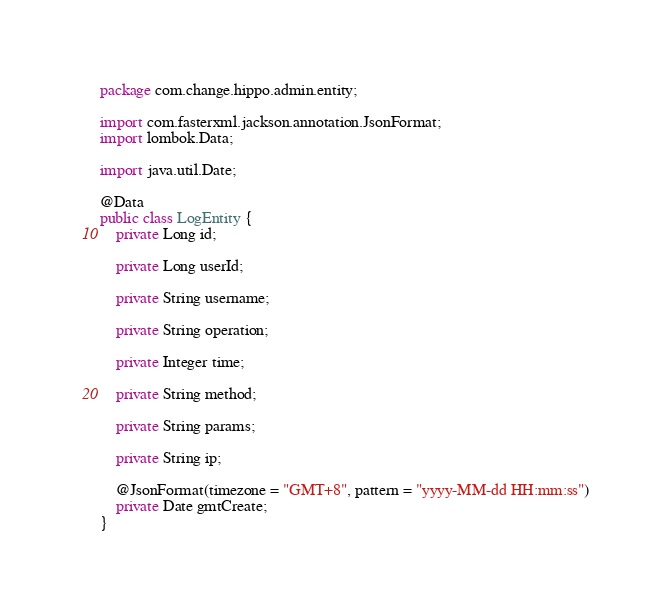Convert code to text. <code><loc_0><loc_0><loc_500><loc_500><_Java_>package com.change.hippo.admin.entity;

import com.fasterxml.jackson.annotation.JsonFormat;
import lombok.Data;

import java.util.Date;

@Data
public class LogEntity {
	private Long id;

	private Long userId;

	private String username;

	private String operation;

	private Integer time;

	private String method;

	private String params;

	private String ip;

	@JsonFormat(timezone = "GMT+8", pattern = "yyyy-MM-dd HH:mm:ss")
	private Date gmtCreate;
}</code> 